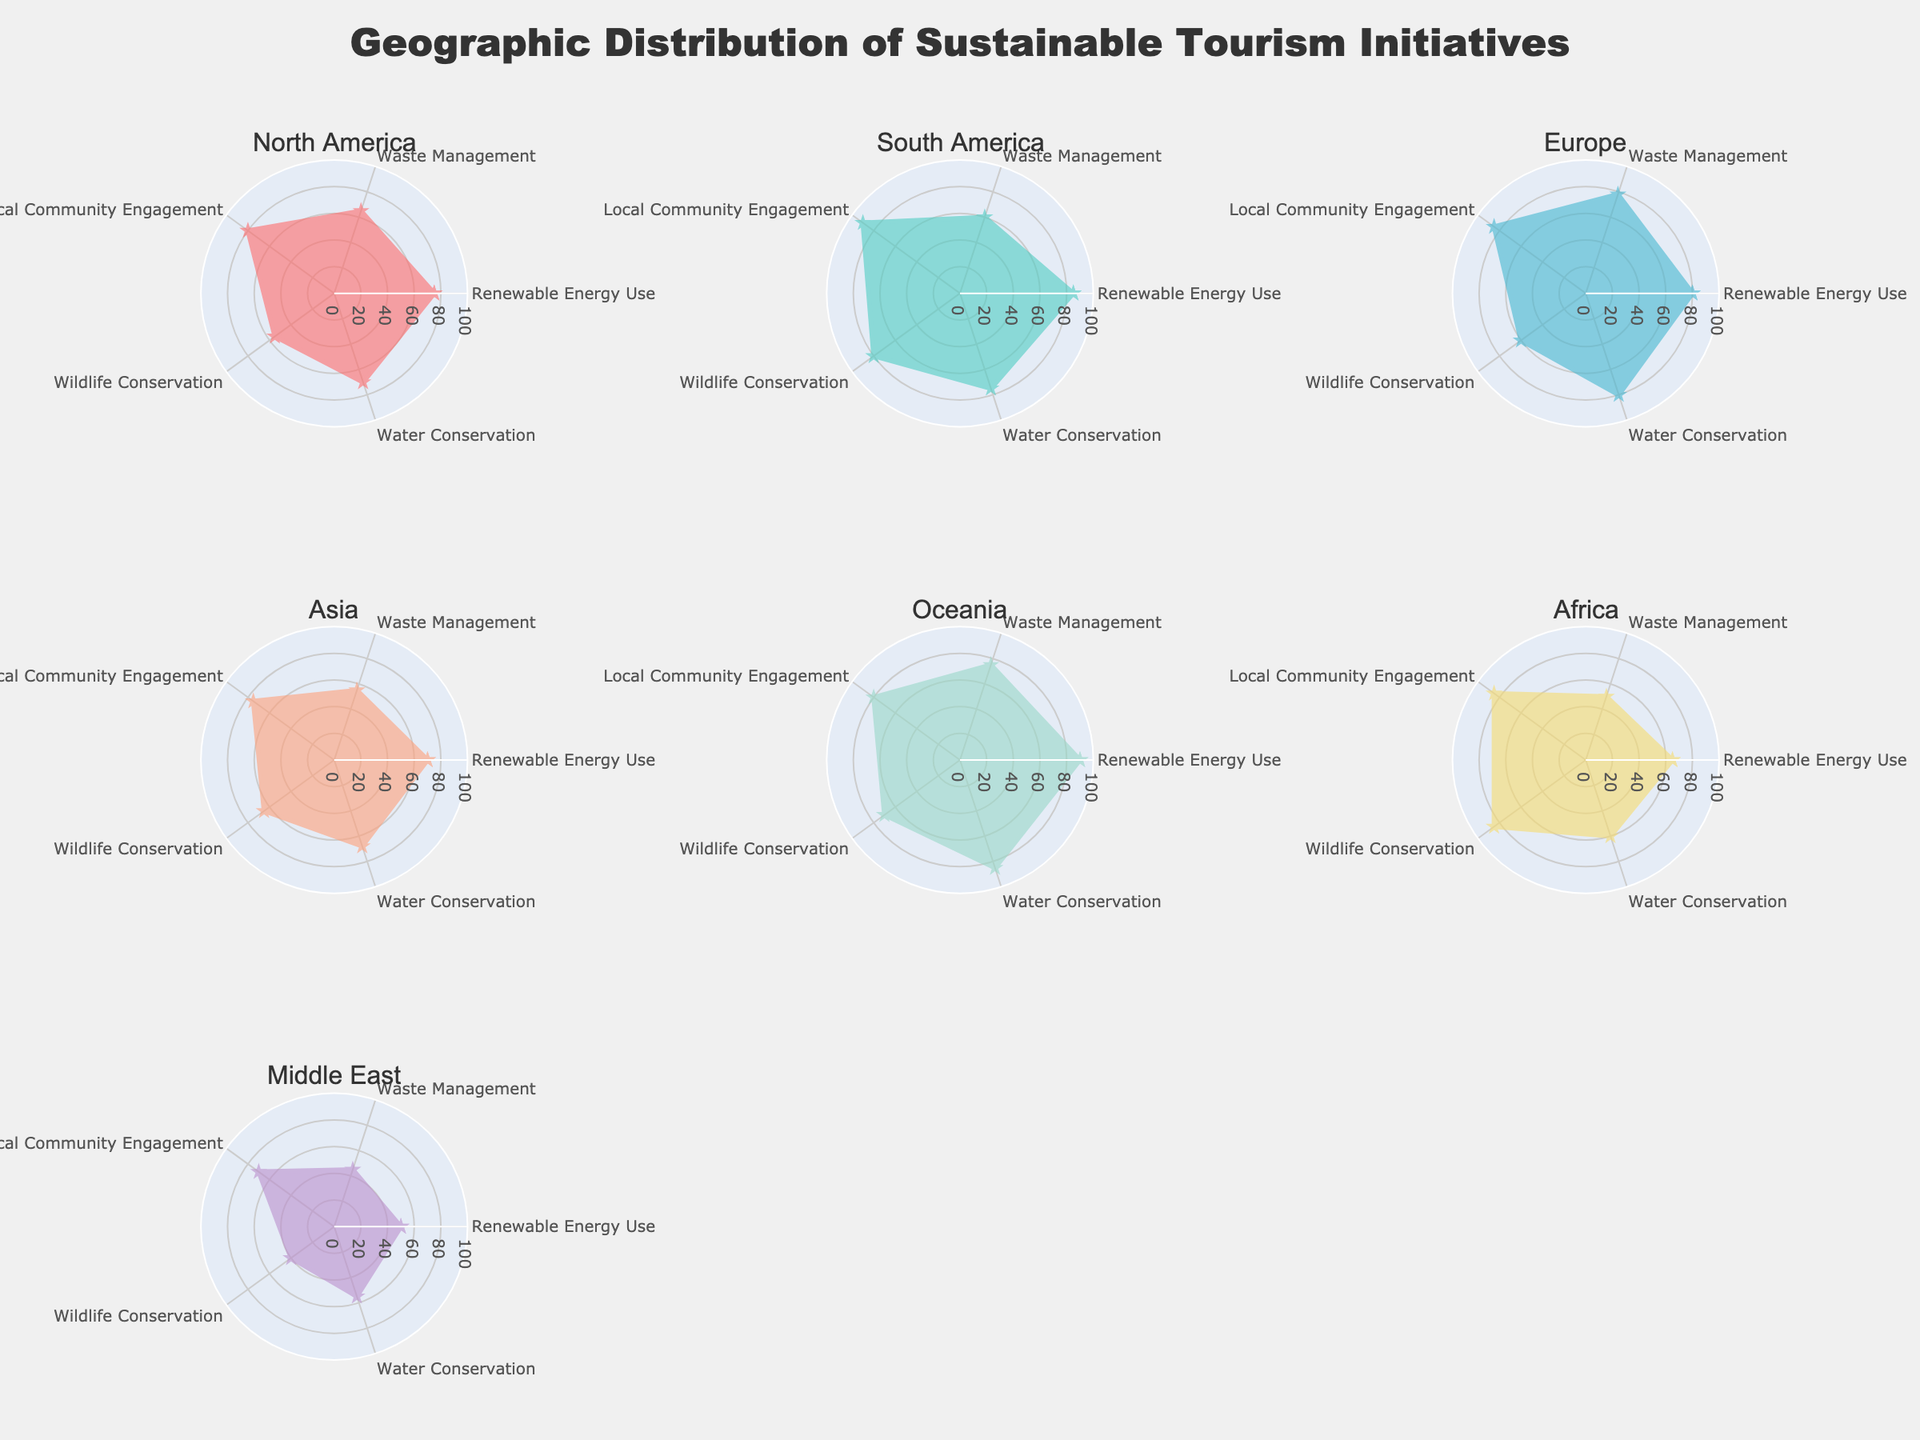Which region has the highest value for wildlife conservation? The radar chart shows the maximum value under the Wildlife Conservation category for the African region, indicated by an 85 on the scale.
Answer: Africa Which region has the lowest renewable energy use? The radar chart shows the lowest value in the Renewable Energy Use category for the Middle East region, indicated by a 50 on the scale.
Answer: Middle East Compare the renewable energy use between North America and Oceania. Which one is higher? The radar chart shows the values for Renewable Energy Use, where North America is depicted with a value of 75 and Oceania with a value of 90. Thus, Oceania has a higher value.
Answer: Oceania Which region shows the most balanced use of sustainable tourism initiatives? A balanced use would imply similar values across all categories. Oceania exhibits similar high values across categories: Renewable Energy Use (90), Waste Management (75), Local Community Engagement (80), Wildlife Conservation (70), Water Conservation (85).
Answer: Oceania What is the average value of water conservation initiatives across all regions? Sum the Water Conservation values from all regions: 70 (NA) + 75 (SA) + 80 (EU) + 68 (Asia) + 85 (Oceania) + 60 (Africa) + 55 (Middle East) = 493. Divide by the number of regions, which is 7. The average is 493/7 ≈ 70.43.
Answer: 70.43 Which region has the second highest local community engagement score? The radar chart shows the highest value for Local Community Engagement in South America (90). The next highest is Africa and Europe, both with a value of 85.
Answer: Africa, Europe Which region has the widest range among its scores for different initiatives? Calculate the range for each region by subtracting the lowest value from the highest value in that region. The widest range is found by checking each region's values. Middle East ranges from 40 to 70, giving a range of 30.
Answer: Middle East Which region performs equally well in Waste Management and Wildlife Conservation? Look for regions where the values for Waste Management and Wildlife Conservation are equal. Africa shows equal values for these categories, both at 85.
Answer: Africa 